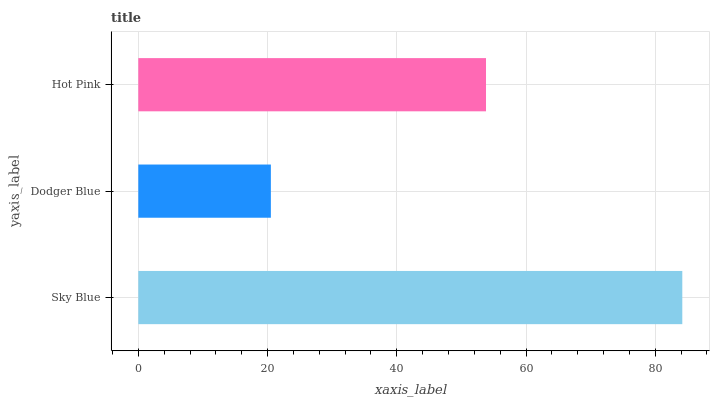Is Dodger Blue the minimum?
Answer yes or no. Yes. Is Sky Blue the maximum?
Answer yes or no. Yes. Is Hot Pink the minimum?
Answer yes or no. No. Is Hot Pink the maximum?
Answer yes or no. No. Is Hot Pink greater than Dodger Blue?
Answer yes or no. Yes. Is Dodger Blue less than Hot Pink?
Answer yes or no. Yes. Is Dodger Blue greater than Hot Pink?
Answer yes or no. No. Is Hot Pink less than Dodger Blue?
Answer yes or no. No. Is Hot Pink the high median?
Answer yes or no. Yes. Is Hot Pink the low median?
Answer yes or no. Yes. Is Dodger Blue the high median?
Answer yes or no. No. Is Sky Blue the low median?
Answer yes or no. No. 